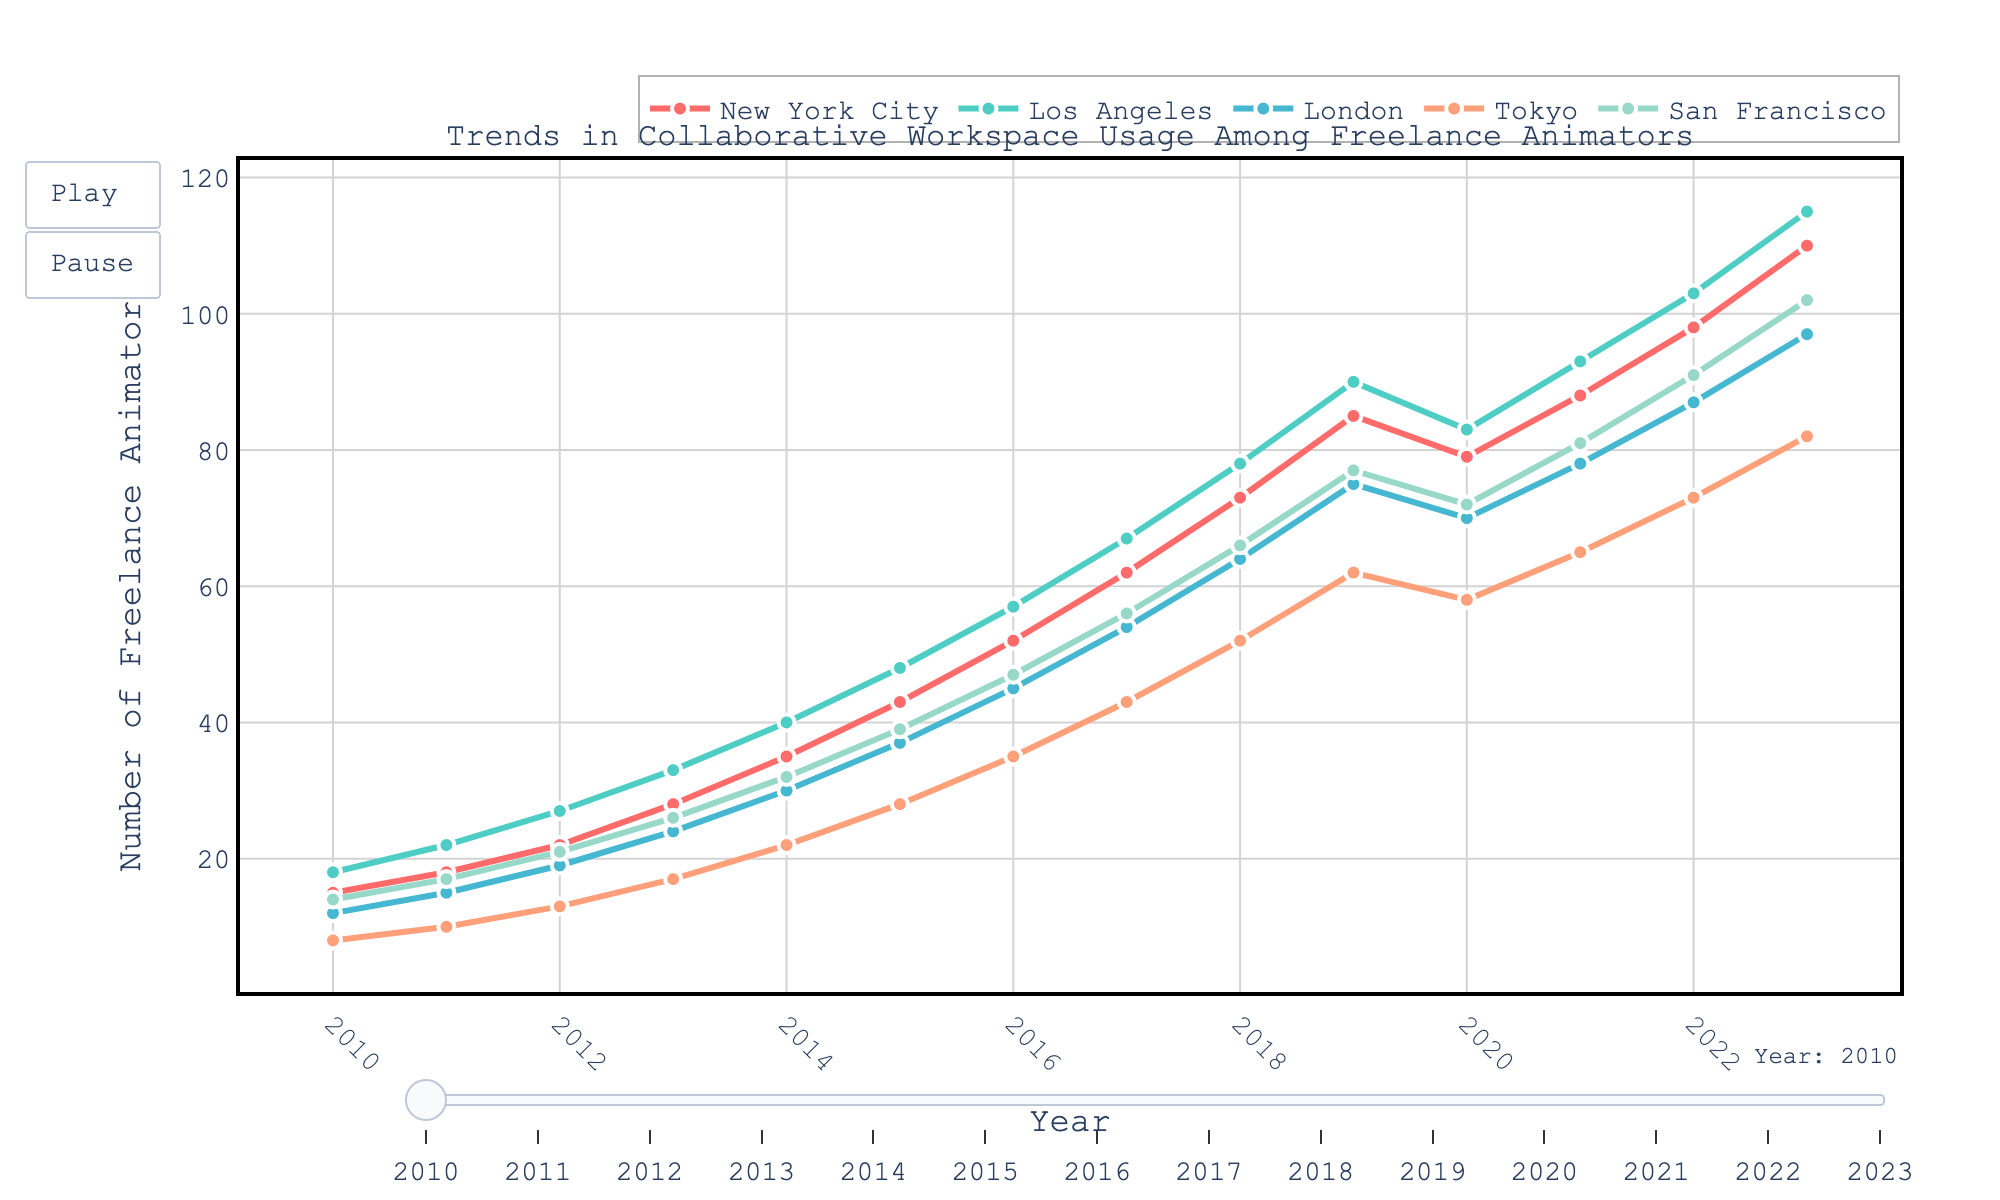What's the trend in the number of freelance animators using collaborative workspaces in New York City from 2010 to 2023? The line chart shows an increasing trend for New York City from 15 in 2010 to 110 in 2023.
Answer: Increasing In which year did London see the first substantial increase in freelance animators from the previous year? In 2011, London saw an increase from 12 to 15 freelance animators, which is the first substantial increase.
Answer: 2011 Compare the number of freelance animators using collaborative workspaces in Los Angeles and San Francisco in 2023. Which city has more? In 2023, Los Angeles has 115 freelance animators while San Francisco has 102. Los Angeles has more.
Answer: Los Angeles How does the usage of collaborative workspaces in Tokyo change from 2017 to 2019? In Tokyo, the number of freelance animators increases from 43 in 2017 to 62 in 2019. This is an increment of 19 animators.
Answer: Increases by 19 Which city shows the fastest growth in collaborative workspace usage from 2010 to 2023? By comparing all the cities, Los Angeles shows the fastest growth, starting from 18 in 2010 and reaching 115 in 2023.
Answer: Los Angeles What was the average number of freelance animators using collaborative workspaces in San Francisco between 2015 and 2020? The numbers for San Francisco between 2015 and 2020 are 39, 47, 56, 66, 77, and 72. The average is calculated as (39 + 47 + 56 + 66 + 77 + 72) / 6 = 57.8333.
Answer: 57.83 What is the total increase in the number of freelance animators in London from 2010 to 2023? In 2010 and 2023, London as 12 and 97 freelance animators respectively. The total increase is 97 - 12 = 85.
Answer: 85 What's the percentage decrease in the number of freelance animators in New York City from 2019 to 2020? In 2019 and 2020, New York City had 85 and 79 freelance animators, respectively. The percentage decrease is ((85 - 79) / 85) * 100 = 7.06%.
Answer: 7.06% Which city consistently had the highest number of freelance animators in every year from 2010 to 2023? By observing the trends, Los Angeles consistently remained the city with the highest number of freelance animators each year from 2010 to 2023.
Answer: Los Angeles 